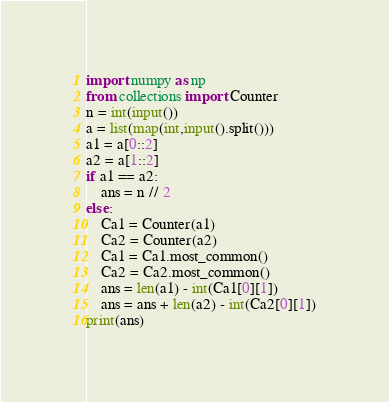Convert code to text. <code><loc_0><loc_0><loc_500><loc_500><_Python_>import numpy as np
from collections import Counter
n = int(input())
a = list(map(int,input().split()))
a1 = a[0::2]
a2 = a[1::2]
if a1 == a2:
    ans = n // 2
else:
    Ca1 = Counter(a1)
    Ca2 = Counter(a2)
    Ca1 = Ca1.most_common()
    Ca2 = Ca2.most_common()
    ans = len(a1) - int(Ca1[0][1])
    ans = ans + len(a2) - int(Ca2[0][1])
print(ans)
</code> 